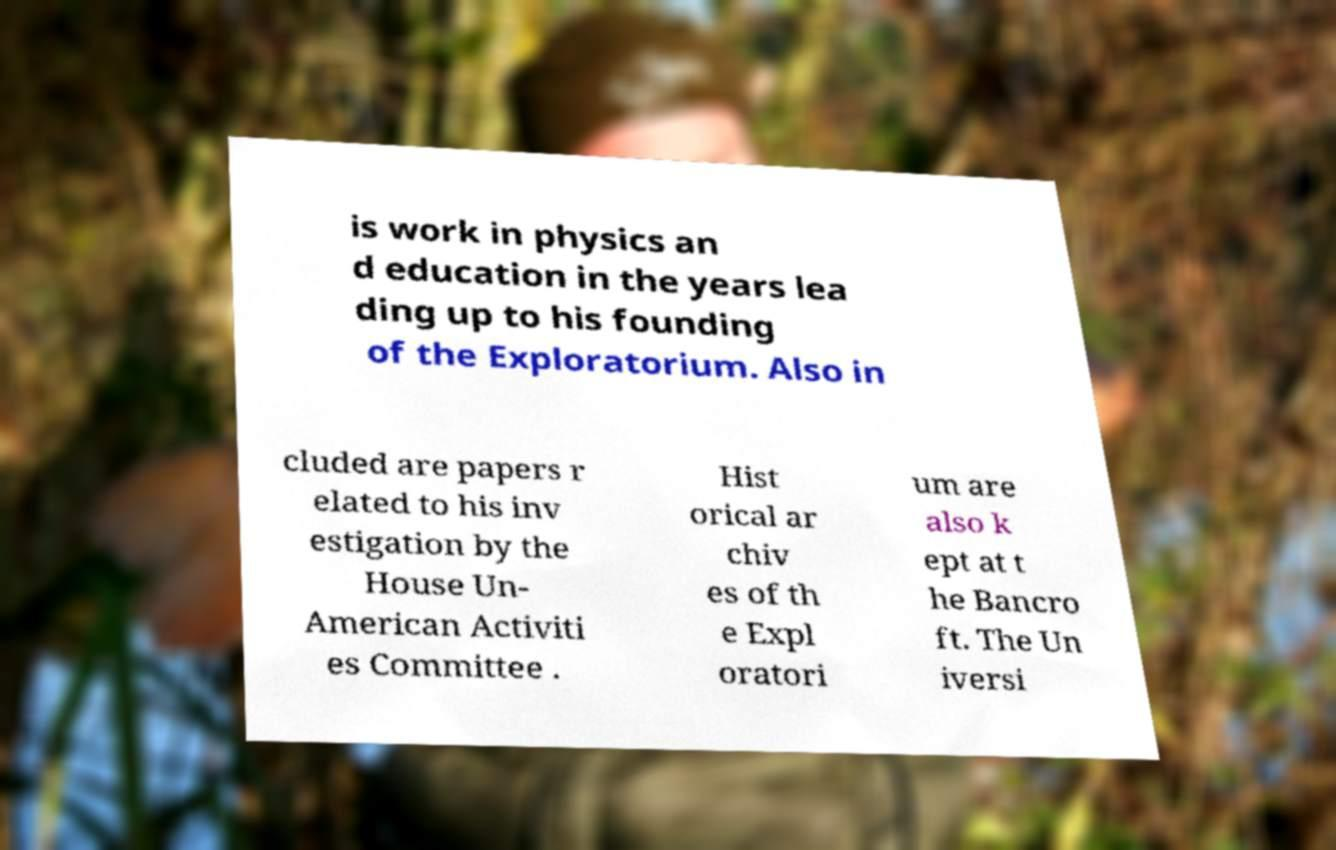What messages or text are displayed in this image? I need them in a readable, typed format. is work in physics an d education in the years lea ding up to his founding of the Exploratorium. Also in cluded are papers r elated to his inv estigation by the House Un- American Activiti es Committee . Hist orical ar chiv es of th e Expl oratori um are also k ept at t he Bancro ft. The Un iversi 